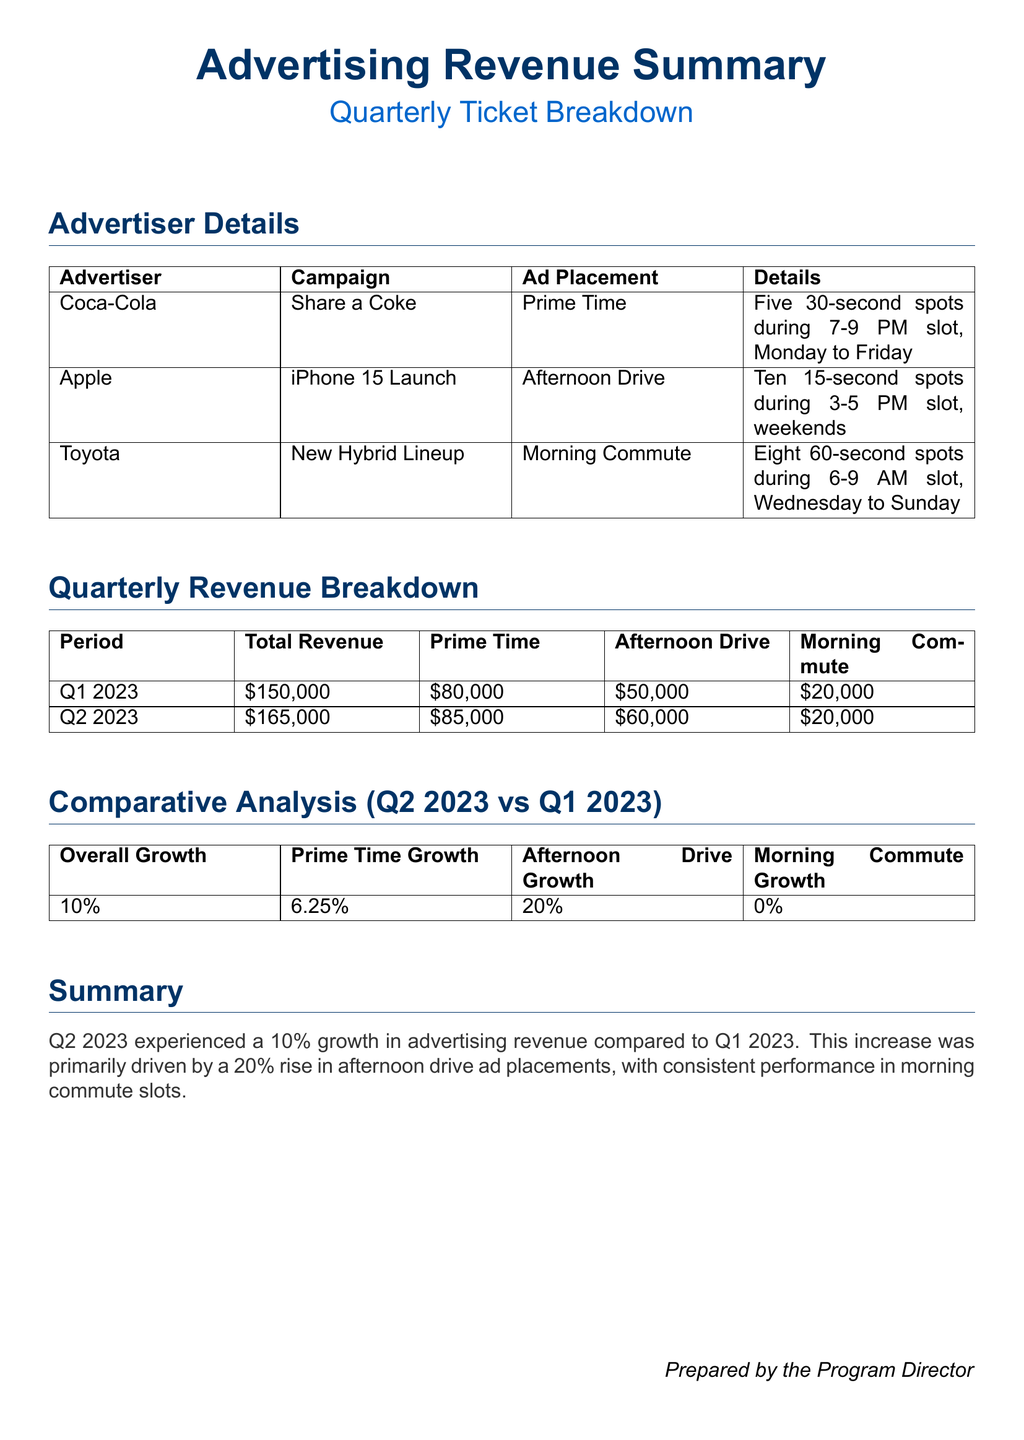What is the total revenue for Q1 2023? The total revenue for Q1 2023 is listed in the Quarterly Revenue Breakdown section.
Answer: $150,000 How many 30-second spots did Coca-Cola purchase? The number of 30-second spots for Coca-Cola is specified in the Advertiser Details section.
Answer: Five What is the ad placement time for the Toyota campaign? The ad placement time for Toyota is indicated in the Advertiser Details section.
Answer: Morning Commute What was the growth percentage for Afternoon Drive from Q1 2023 to Q2 2023? The growth percentage for Afternoon Drive is detailed in the Comparative Analysis section.
Answer: 20% What is the total revenue for Q2 2023? The total revenue for Q2 2023 is stated in the Quarterly Revenue Breakdown section.
Answer: $165,000 Which campaign had the highest revenue in Q2 2023? The campaign with the highest revenue is reflected in the Prime Time revenue breakdown.
Answer: Coca-Cola What percentage growth did overall advertising revenue experience from Q1 to Q2 2023? The percentage growth in overall advertising revenue is given in the Comparative Analysis section.
Answer: 10% How many spots did Apple purchase during the Afternoon Drive? The number of 15-second spots for Apple is listed in the Advertiser Details section.
Answer: Ten What is the total revenue for Morning Commute in Q2 2023? The total revenue for Morning Commute in Q2 2023 can be found in the Quarterly Revenue Breakdown section.
Answer: $20,000 